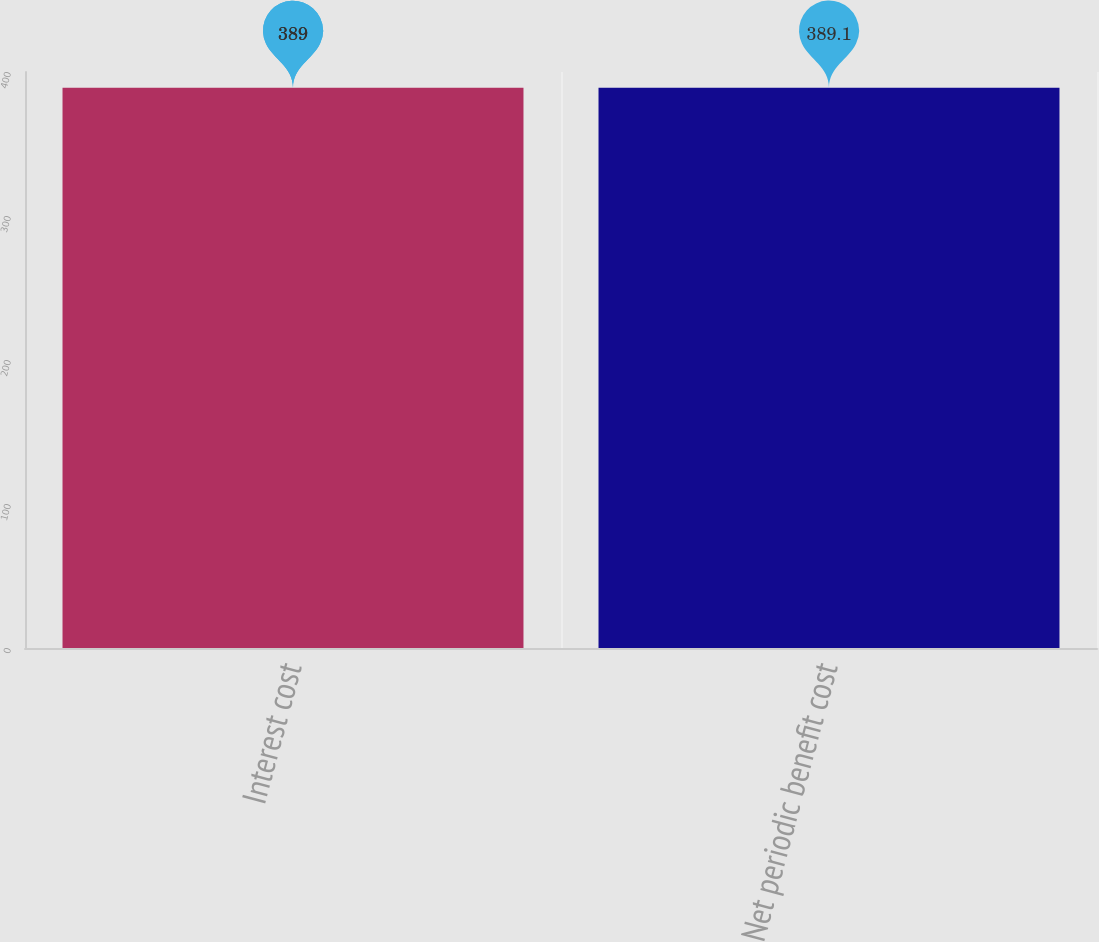Convert chart. <chart><loc_0><loc_0><loc_500><loc_500><bar_chart><fcel>Interest cost<fcel>Net periodic benefit cost<nl><fcel>389<fcel>389.1<nl></chart> 